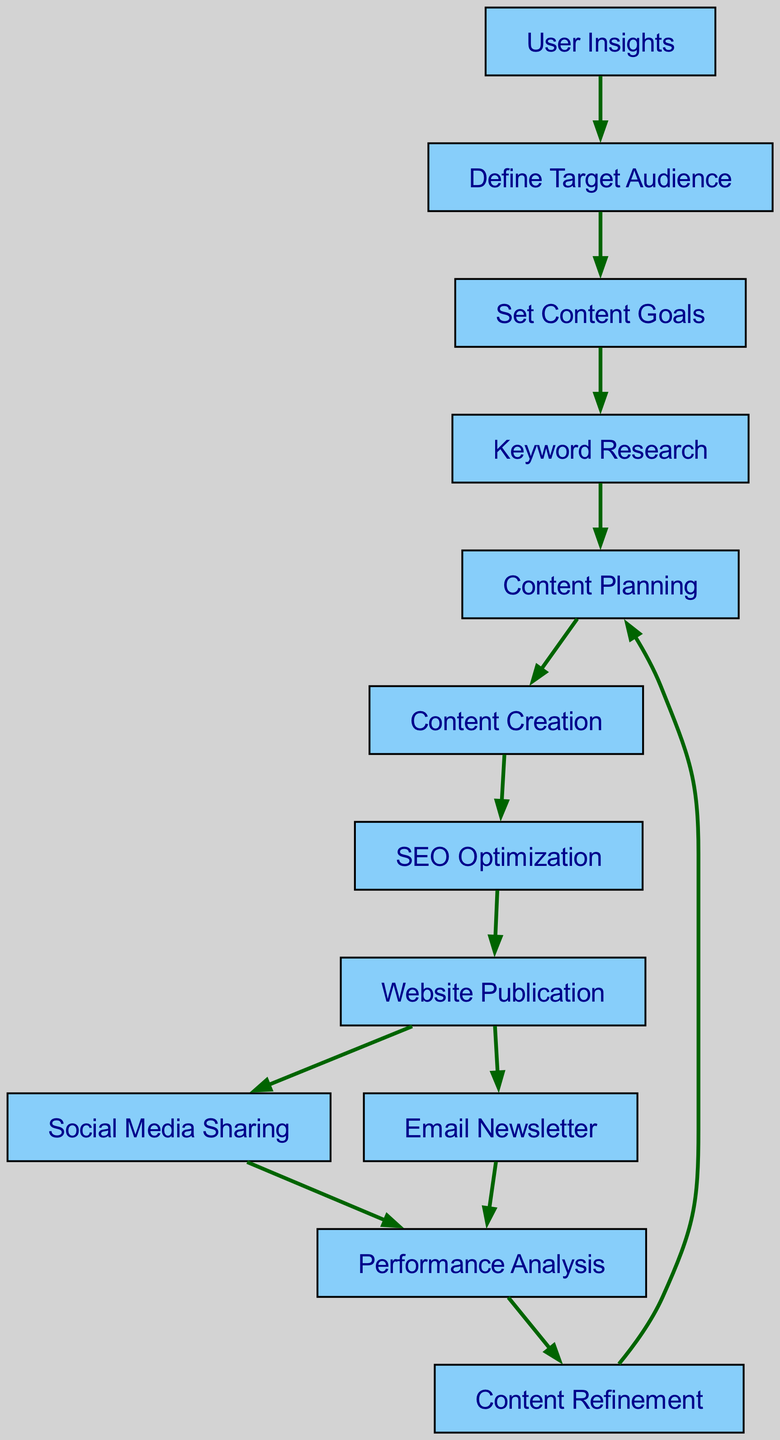What is the first node in the flowchart? The first node in the flowchart is "User Insights", which is the starting point representing user research and insights.
Answer: User Insights How many edges are there in total? By counting the connections between the nodes, there are 13 edges that indicate the flow of the content marketing strategy.
Answer: 13 What nodes lead directly to "Content Creation"? The node that leads directly to "Content Creation" is "Content Planning", which indicates the process that precedes content creation.
Answer: Content Planning Which node is the final step before the content is published on the website? The final step before publication is "SEO Optimization", as it refines the content for search engine performance prior to going live.
Answer: SEO Optimization What happens after "Performance Analysis"? The step that follows "Performance Analysis" is "Content Refinement", indicating that performance data is used to improve the content.
Answer: Content Refinement How many nodes are directly distributed from "Website Publication"? The nodes that are directly distributed from "Website Publication" are "Social Media Sharing" and "Email Newsletter", amounting to two distribution channels.
Answer: 2 Which node represents the first analytical stage in the process? The first analytical stage is represented by "Performance Analysis", which assesses content effectiveness after it has been published.
Answer: Performance Analysis What is required before setting content goals? "Define Target Audience" is required before setting content goals, indicating the need to understand the audience first.
Answer: Define Target Audience What process leads to "Keyword Research"? The process that leads to "Keyword Research" is "Set Content Goals", which outlines the objectives necessary for conducting effective keyword research.
Answer: Set Content Goals 